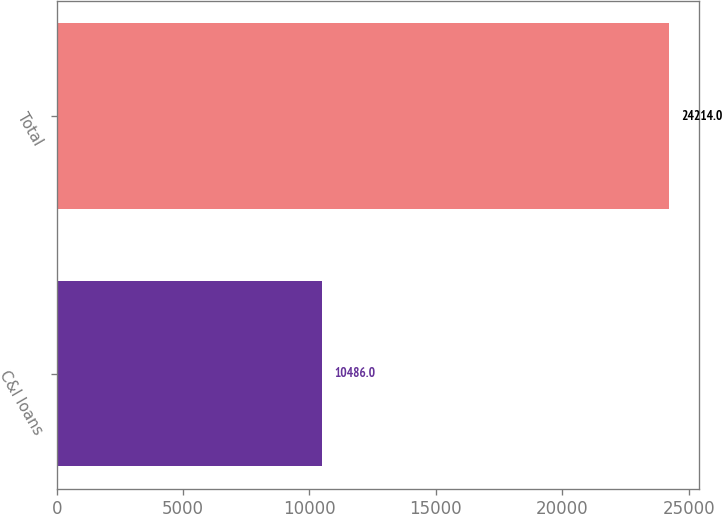Convert chart to OTSL. <chart><loc_0><loc_0><loc_500><loc_500><bar_chart><fcel>C&I loans<fcel>Total<nl><fcel>10486<fcel>24214<nl></chart> 